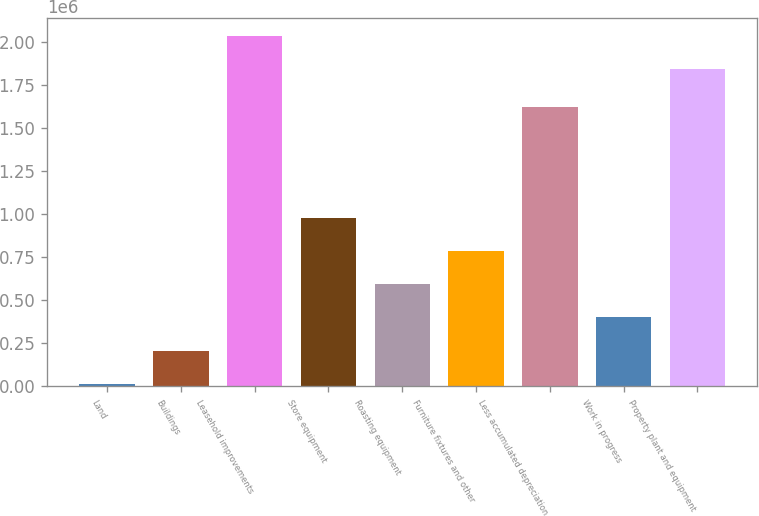<chart> <loc_0><loc_0><loc_500><loc_500><bar_chart><fcel>Land<fcel>Buildings<fcel>Leasehold improvements<fcel>Store equipment<fcel>Roasting equipment<fcel>Furniture fixtures and other<fcel>Less accumulated depreciation<fcel>Work in progress<fcel>Property plant and equipment<nl><fcel>13833<fcel>207246<fcel>2.03543e+06<fcel>980898<fcel>594072<fcel>787485<fcel>1.62556e+06<fcel>400659<fcel>1.84202e+06<nl></chart> 